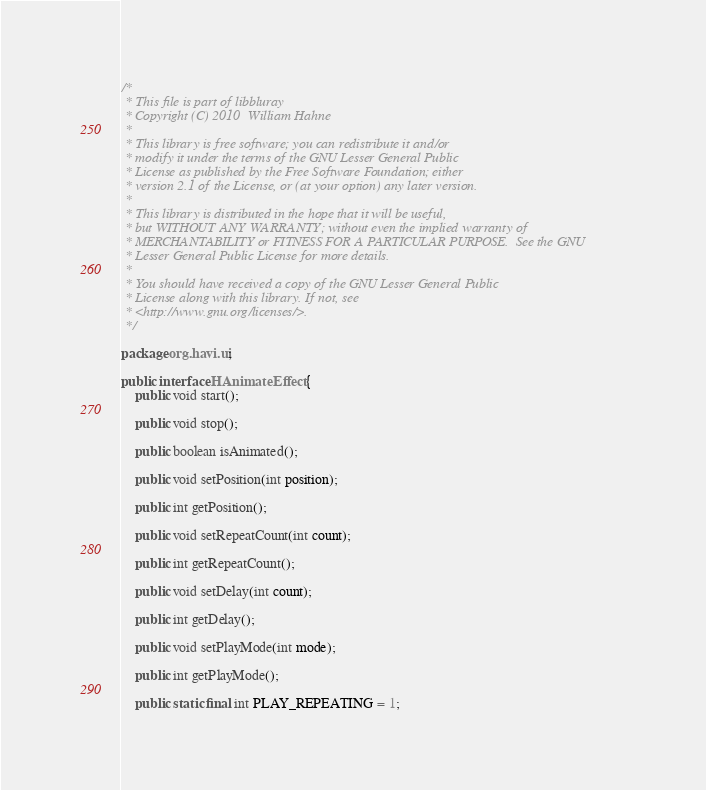<code> <loc_0><loc_0><loc_500><loc_500><_Java_>/*
 * This file is part of libbluray
 * Copyright (C) 2010  William Hahne
 *
 * This library is free software; you can redistribute it and/or
 * modify it under the terms of the GNU Lesser General Public
 * License as published by the Free Software Foundation; either
 * version 2.1 of the License, or (at your option) any later version.
 *
 * This library is distributed in the hope that it will be useful,
 * but WITHOUT ANY WARRANTY; without even the implied warranty of
 * MERCHANTABILITY or FITNESS FOR A PARTICULAR PURPOSE.  See the GNU
 * Lesser General Public License for more details.
 *
 * You should have received a copy of the GNU Lesser General Public
 * License along with this library. If not, see
 * <http://www.gnu.org/licenses/>.
 */

package org.havi.ui;

public interface HAnimateEffect {
    public void start();

    public void stop();

    public boolean isAnimated();

    public void setPosition(int position);

    public int getPosition();

    public void setRepeatCount(int count);

    public int getRepeatCount();

    public void setDelay(int count);

    public int getDelay();

    public void setPlayMode(int mode);

    public int getPlayMode();

    public static final int PLAY_REPEATING = 1;</code> 